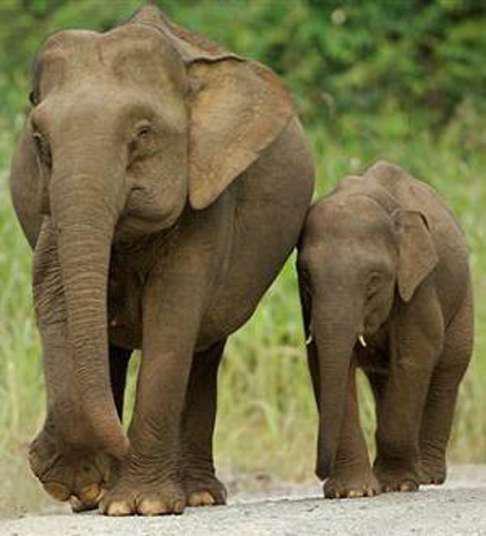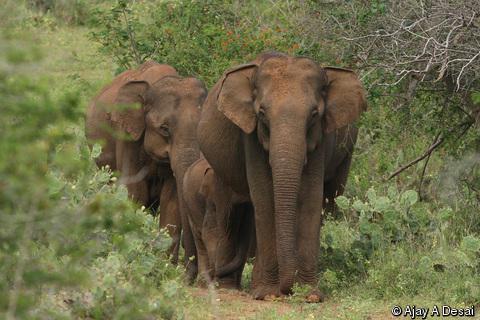The first image is the image on the left, the second image is the image on the right. For the images displayed, is the sentence "There are two elephants in total." factually correct? Answer yes or no. No. 